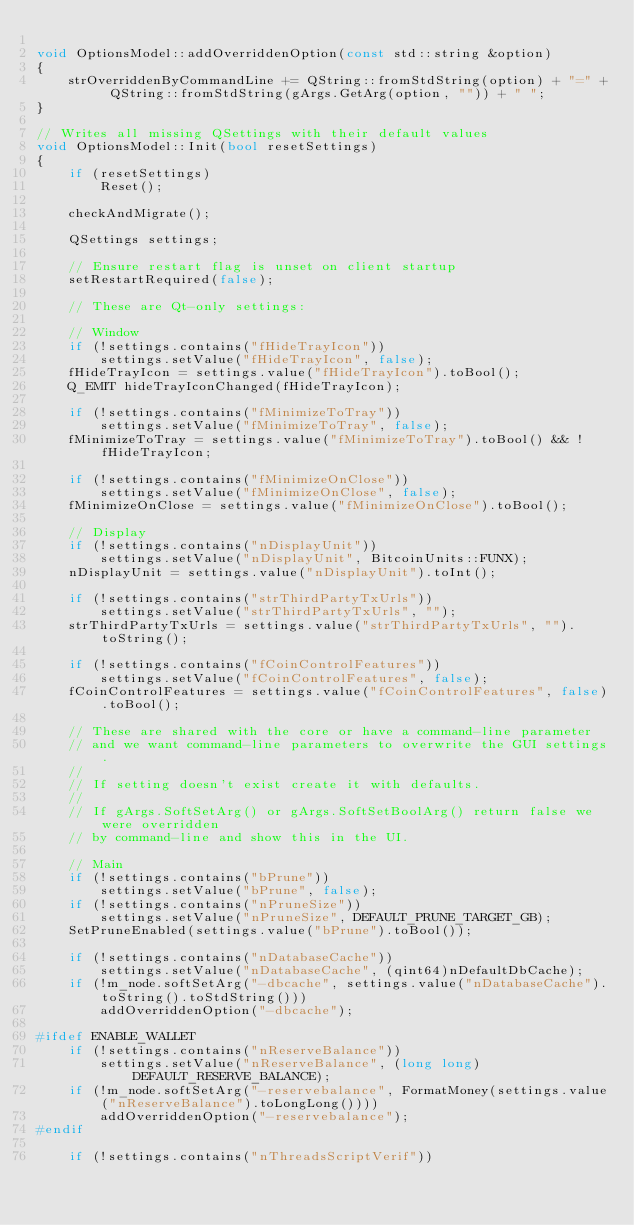Convert code to text. <code><loc_0><loc_0><loc_500><loc_500><_C++_>
void OptionsModel::addOverriddenOption(const std::string &option)
{
    strOverriddenByCommandLine += QString::fromStdString(option) + "=" + QString::fromStdString(gArgs.GetArg(option, "")) + " ";
}

// Writes all missing QSettings with their default values
void OptionsModel::Init(bool resetSettings)
{
    if (resetSettings)
        Reset();

    checkAndMigrate();

    QSettings settings;

    // Ensure restart flag is unset on client startup
    setRestartRequired(false);

    // These are Qt-only settings:

    // Window
    if (!settings.contains("fHideTrayIcon"))
        settings.setValue("fHideTrayIcon", false);
    fHideTrayIcon = settings.value("fHideTrayIcon").toBool();
    Q_EMIT hideTrayIconChanged(fHideTrayIcon);

    if (!settings.contains("fMinimizeToTray"))
        settings.setValue("fMinimizeToTray", false);
    fMinimizeToTray = settings.value("fMinimizeToTray").toBool() && !fHideTrayIcon;

    if (!settings.contains("fMinimizeOnClose"))
        settings.setValue("fMinimizeOnClose", false);
    fMinimizeOnClose = settings.value("fMinimizeOnClose").toBool();

    // Display
    if (!settings.contains("nDisplayUnit"))
        settings.setValue("nDisplayUnit", BitcoinUnits::FUNX);
    nDisplayUnit = settings.value("nDisplayUnit").toInt();

    if (!settings.contains("strThirdPartyTxUrls"))
        settings.setValue("strThirdPartyTxUrls", "");
    strThirdPartyTxUrls = settings.value("strThirdPartyTxUrls", "").toString();

    if (!settings.contains("fCoinControlFeatures"))
        settings.setValue("fCoinControlFeatures", false);
    fCoinControlFeatures = settings.value("fCoinControlFeatures", false).toBool();

    // These are shared with the core or have a command-line parameter
    // and we want command-line parameters to overwrite the GUI settings.
    //
    // If setting doesn't exist create it with defaults.
    //
    // If gArgs.SoftSetArg() or gArgs.SoftSetBoolArg() return false we were overridden
    // by command-line and show this in the UI.

    // Main
    if (!settings.contains("bPrune"))
        settings.setValue("bPrune", false);
    if (!settings.contains("nPruneSize"))
        settings.setValue("nPruneSize", DEFAULT_PRUNE_TARGET_GB);
    SetPruneEnabled(settings.value("bPrune").toBool());

    if (!settings.contains("nDatabaseCache"))
        settings.setValue("nDatabaseCache", (qint64)nDefaultDbCache);
    if (!m_node.softSetArg("-dbcache", settings.value("nDatabaseCache").toString().toStdString()))
        addOverriddenOption("-dbcache");

#ifdef ENABLE_WALLET
    if (!settings.contains("nReserveBalance"))
        settings.setValue("nReserveBalance", (long long)DEFAULT_RESERVE_BALANCE);
    if (!m_node.softSetArg("-reservebalance", FormatMoney(settings.value("nReserveBalance").toLongLong())))
        addOverriddenOption("-reservebalance");
#endif

    if (!settings.contains("nThreadsScriptVerif"))</code> 